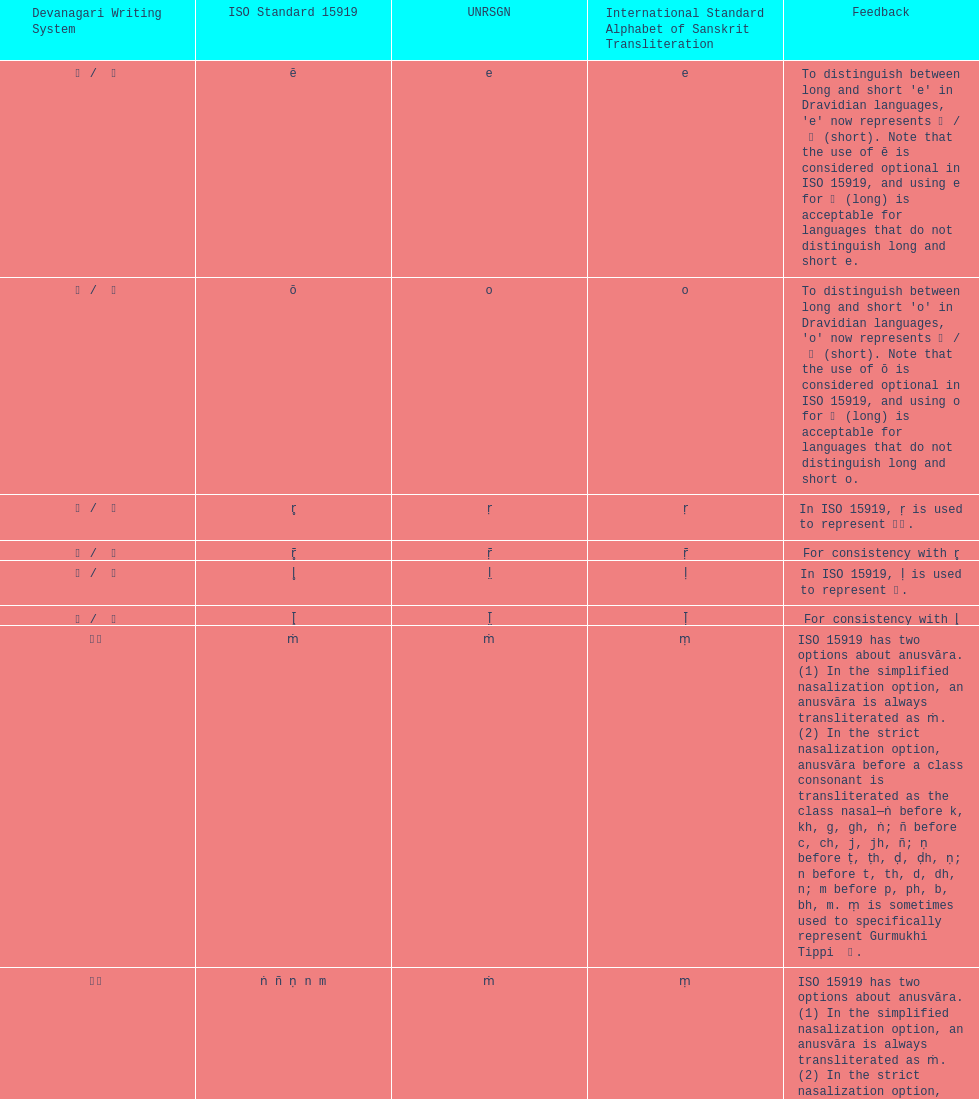What is listed previous to in iso 15919, &#7735; is used to represent &#2355;. under comments? For consistency with r̥. 